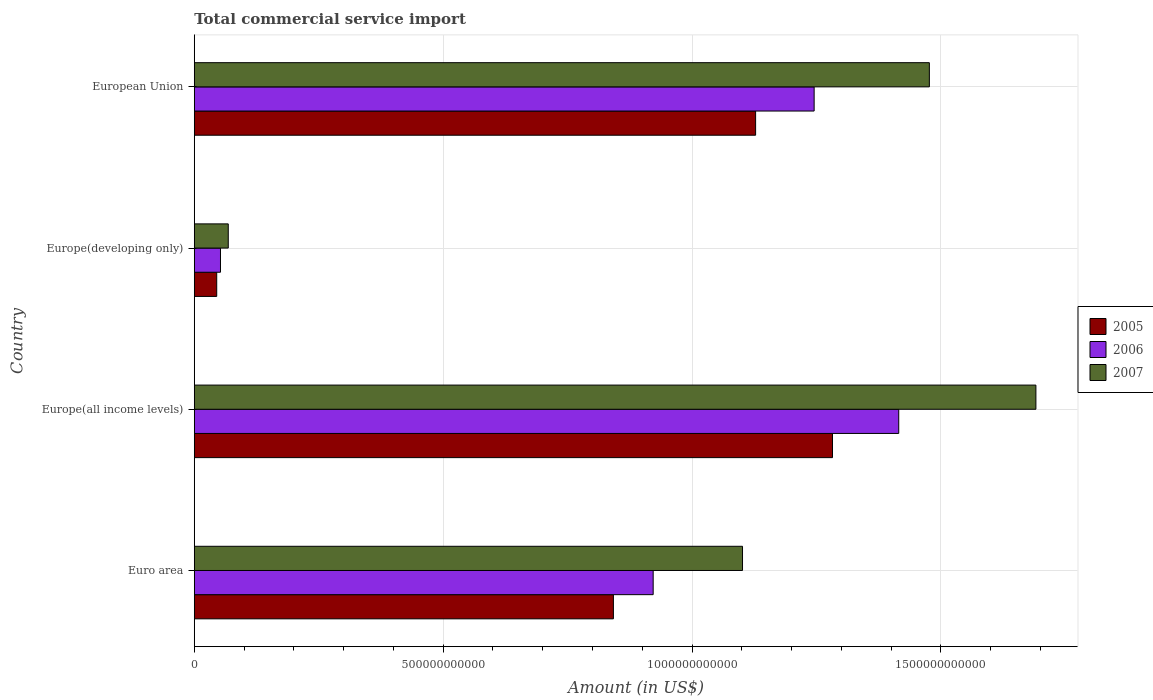How many different coloured bars are there?
Ensure brevity in your answer.  3. What is the label of the 4th group of bars from the top?
Make the answer very short. Euro area. In how many cases, is the number of bars for a given country not equal to the number of legend labels?
Offer a terse response. 0. What is the total commercial service import in 2006 in European Union?
Your response must be concise. 1.25e+12. Across all countries, what is the maximum total commercial service import in 2006?
Provide a succinct answer. 1.42e+12. Across all countries, what is the minimum total commercial service import in 2005?
Make the answer very short. 4.51e+1. In which country was the total commercial service import in 2007 maximum?
Provide a succinct answer. Europe(all income levels). In which country was the total commercial service import in 2005 minimum?
Provide a succinct answer. Europe(developing only). What is the total total commercial service import in 2007 in the graph?
Offer a very short reply. 4.34e+12. What is the difference between the total commercial service import in 2006 in Euro area and that in Europe(developing only)?
Offer a terse response. 8.69e+11. What is the difference between the total commercial service import in 2005 in Euro area and the total commercial service import in 2006 in Europe(all income levels)?
Offer a terse response. -5.73e+11. What is the average total commercial service import in 2005 per country?
Your answer should be compact. 8.24e+11. What is the difference between the total commercial service import in 2005 and total commercial service import in 2007 in Euro area?
Make the answer very short. -2.59e+11. In how many countries, is the total commercial service import in 2005 greater than 700000000000 US$?
Keep it short and to the point. 3. What is the ratio of the total commercial service import in 2007 in Europe(developing only) to that in European Union?
Offer a very short reply. 0.05. Is the total commercial service import in 2005 in Europe(developing only) less than that in European Union?
Provide a short and direct response. Yes. What is the difference between the highest and the second highest total commercial service import in 2007?
Provide a succinct answer. 2.14e+11. What is the difference between the highest and the lowest total commercial service import in 2006?
Provide a short and direct response. 1.36e+12. In how many countries, is the total commercial service import in 2005 greater than the average total commercial service import in 2005 taken over all countries?
Provide a short and direct response. 3. What does the 2nd bar from the bottom in Euro area represents?
Provide a succinct answer. 2006. Are all the bars in the graph horizontal?
Keep it short and to the point. Yes. How many countries are there in the graph?
Ensure brevity in your answer.  4. What is the difference between two consecutive major ticks on the X-axis?
Give a very brief answer. 5.00e+11. How many legend labels are there?
Give a very brief answer. 3. How are the legend labels stacked?
Your answer should be compact. Vertical. What is the title of the graph?
Your answer should be compact. Total commercial service import. What is the Amount (in US$) of 2005 in Euro area?
Give a very brief answer. 8.42e+11. What is the Amount (in US$) in 2006 in Euro area?
Ensure brevity in your answer.  9.22e+11. What is the Amount (in US$) in 2007 in Euro area?
Keep it short and to the point. 1.10e+12. What is the Amount (in US$) in 2005 in Europe(all income levels)?
Make the answer very short. 1.28e+12. What is the Amount (in US$) in 2006 in Europe(all income levels)?
Make the answer very short. 1.42e+12. What is the Amount (in US$) of 2007 in Europe(all income levels)?
Provide a succinct answer. 1.69e+12. What is the Amount (in US$) of 2005 in Europe(developing only)?
Provide a succinct answer. 4.51e+1. What is the Amount (in US$) of 2006 in Europe(developing only)?
Give a very brief answer. 5.27e+1. What is the Amount (in US$) of 2007 in Europe(developing only)?
Give a very brief answer. 6.83e+1. What is the Amount (in US$) in 2005 in European Union?
Give a very brief answer. 1.13e+12. What is the Amount (in US$) in 2006 in European Union?
Offer a terse response. 1.25e+12. What is the Amount (in US$) in 2007 in European Union?
Provide a short and direct response. 1.48e+12. Across all countries, what is the maximum Amount (in US$) in 2005?
Provide a succinct answer. 1.28e+12. Across all countries, what is the maximum Amount (in US$) of 2006?
Your answer should be very brief. 1.42e+12. Across all countries, what is the maximum Amount (in US$) in 2007?
Your response must be concise. 1.69e+12. Across all countries, what is the minimum Amount (in US$) in 2005?
Keep it short and to the point. 4.51e+1. Across all countries, what is the minimum Amount (in US$) of 2006?
Offer a very short reply. 5.27e+1. Across all countries, what is the minimum Amount (in US$) of 2007?
Offer a terse response. 6.83e+1. What is the total Amount (in US$) of 2005 in the graph?
Give a very brief answer. 3.30e+12. What is the total Amount (in US$) of 2006 in the graph?
Ensure brevity in your answer.  3.64e+12. What is the total Amount (in US$) in 2007 in the graph?
Ensure brevity in your answer.  4.34e+12. What is the difference between the Amount (in US$) in 2005 in Euro area and that in Europe(all income levels)?
Your response must be concise. -4.40e+11. What is the difference between the Amount (in US$) of 2006 in Euro area and that in Europe(all income levels)?
Offer a terse response. -4.93e+11. What is the difference between the Amount (in US$) of 2007 in Euro area and that in Europe(all income levels)?
Your answer should be compact. -5.89e+11. What is the difference between the Amount (in US$) of 2005 in Euro area and that in Europe(developing only)?
Make the answer very short. 7.97e+11. What is the difference between the Amount (in US$) of 2006 in Euro area and that in Europe(developing only)?
Provide a short and direct response. 8.69e+11. What is the difference between the Amount (in US$) in 2007 in Euro area and that in Europe(developing only)?
Offer a very short reply. 1.03e+12. What is the difference between the Amount (in US$) of 2005 in Euro area and that in European Union?
Offer a terse response. -2.86e+11. What is the difference between the Amount (in US$) of 2006 in Euro area and that in European Union?
Your answer should be compact. -3.23e+11. What is the difference between the Amount (in US$) of 2007 in Euro area and that in European Union?
Offer a very short reply. -3.75e+11. What is the difference between the Amount (in US$) of 2005 in Europe(all income levels) and that in Europe(developing only)?
Your answer should be compact. 1.24e+12. What is the difference between the Amount (in US$) in 2006 in Europe(all income levels) and that in Europe(developing only)?
Your response must be concise. 1.36e+12. What is the difference between the Amount (in US$) in 2007 in Europe(all income levels) and that in Europe(developing only)?
Your answer should be very brief. 1.62e+12. What is the difference between the Amount (in US$) of 2005 in Europe(all income levels) and that in European Union?
Give a very brief answer. 1.55e+11. What is the difference between the Amount (in US$) in 2006 in Europe(all income levels) and that in European Union?
Your answer should be very brief. 1.70e+11. What is the difference between the Amount (in US$) in 2007 in Europe(all income levels) and that in European Union?
Your answer should be compact. 2.14e+11. What is the difference between the Amount (in US$) of 2005 in Europe(developing only) and that in European Union?
Keep it short and to the point. -1.08e+12. What is the difference between the Amount (in US$) in 2006 in Europe(developing only) and that in European Union?
Offer a terse response. -1.19e+12. What is the difference between the Amount (in US$) in 2007 in Europe(developing only) and that in European Union?
Your response must be concise. -1.41e+12. What is the difference between the Amount (in US$) in 2005 in Euro area and the Amount (in US$) in 2006 in Europe(all income levels)?
Make the answer very short. -5.73e+11. What is the difference between the Amount (in US$) of 2005 in Euro area and the Amount (in US$) of 2007 in Europe(all income levels)?
Offer a terse response. -8.49e+11. What is the difference between the Amount (in US$) in 2006 in Euro area and the Amount (in US$) in 2007 in Europe(all income levels)?
Your answer should be compact. -7.69e+11. What is the difference between the Amount (in US$) in 2005 in Euro area and the Amount (in US$) in 2006 in Europe(developing only)?
Provide a succinct answer. 7.89e+11. What is the difference between the Amount (in US$) in 2005 in Euro area and the Amount (in US$) in 2007 in Europe(developing only)?
Ensure brevity in your answer.  7.74e+11. What is the difference between the Amount (in US$) of 2006 in Euro area and the Amount (in US$) of 2007 in Europe(developing only)?
Keep it short and to the point. 8.54e+11. What is the difference between the Amount (in US$) of 2005 in Euro area and the Amount (in US$) of 2006 in European Union?
Give a very brief answer. -4.03e+11. What is the difference between the Amount (in US$) of 2005 in Euro area and the Amount (in US$) of 2007 in European Union?
Your response must be concise. -6.35e+11. What is the difference between the Amount (in US$) of 2006 in Euro area and the Amount (in US$) of 2007 in European Union?
Your response must be concise. -5.55e+11. What is the difference between the Amount (in US$) of 2005 in Europe(all income levels) and the Amount (in US$) of 2006 in Europe(developing only)?
Your answer should be very brief. 1.23e+12. What is the difference between the Amount (in US$) in 2005 in Europe(all income levels) and the Amount (in US$) in 2007 in Europe(developing only)?
Give a very brief answer. 1.21e+12. What is the difference between the Amount (in US$) of 2006 in Europe(all income levels) and the Amount (in US$) of 2007 in Europe(developing only)?
Offer a very short reply. 1.35e+12. What is the difference between the Amount (in US$) of 2005 in Europe(all income levels) and the Amount (in US$) of 2006 in European Union?
Offer a terse response. 3.69e+1. What is the difference between the Amount (in US$) of 2005 in Europe(all income levels) and the Amount (in US$) of 2007 in European Union?
Your response must be concise. -1.95e+11. What is the difference between the Amount (in US$) of 2006 in Europe(all income levels) and the Amount (in US$) of 2007 in European Union?
Your answer should be compact. -6.15e+1. What is the difference between the Amount (in US$) in 2005 in Europe(developing only) and the Amount (in US$) in 2006 in European Union?
Give a very brief answer. -1.20e+12. What is the difference between the Amount (in US$) of 2005 in Europe(developing only) and the Amount (in US$) of 2007 in European Union?
Provide a short and direct response. -1.43e+12. What is the difference between the Amount (in US$) of 2006 in Europe(developing only) and the Amount (in US$) of 2007 in European Union?
Your response must be concise. -1.42e+12. What is the average Amount (in US$) in 2005 per country?
Provide a short and direct response. 8.24e+11. What is the average Amount (in US$) of 2006 per country?
Your response must be concise. 9.09e+11. What is the average Amount (in US$) of 2007 per country?
Provide a short and direct response. 1.08e+12. What is the difference between the Amount (in US$) in 2005 and Amount (in US$) in 2006 in Euro area?
Make the answer very short. -7.99e+1. What is the difference between the Amount (in US$) of 2005 and Amount (in US$) of 2007 in Euro area?
Ensure brevity in your answer.  -2.59e+11. What is the difference between the Amount (in US$) in 2006 and Amount (in US$) in 2007 in Euro area?
Offer a very short reply. -1.80e+11. What is the difference between the Amount (in US$) in 2005 and Amount (in US$) in 2006 in Europe(all income levels)?
Ensure brevity in your answer.  -1.33e+11. What is the difference between the Amount (in US$) of 2005 and Amount (in US$) of 2007 in Europe(all income levels)?
Provide a short and direct response. -4.09e+11. What is the difference between the Amount (in US$) in 2006 and Amount (in US$) in 2007 in Europe(all income levels)?
Ensure brevity in your answer.  -2.76e+11. What is the difference between the Amount (in US$) in 2005 and Amount (in US$) in 2006 in Europe(developing only)?
Make the answer very short. -7.54e+09. What is the difference between the Amount (in US$) in 2005 and Amount (in US$) in 2007 in Europe(developing only)?
Your response must be concise. -2.32e+1. What is the difference between the Amount (in US$) in 2006 and Amount (in US$) in 2007 in Europe(developing only)?
Offer a very short reply. -1.56e+1. What is the difference between the Amount (in US$) in 2005 and Amount (in US$) in 2006 in European Union?
Provide a short and direct response. -1.18e+11. What is the difference between the Amount (in US$) in 2005 and Amount (in US$) in 2007 in European Union?
Give a very brief answer. -3.49e+11. What is the difference between the Amount (in US$) of 2006 and Amount (in US$) of 2007 in European Union?
Offer a terse response. -2.31e+11. What is the ratio of the Amount (in US$) in 2005 in Euro area to that in Europe(all income levels)?
Make the answer very short. 0.66. What is the ratio of the Amount (in US$) in 2006 in Euro area to that in Europe(all income levels)?
Your answer should be very brief. 0.65. What is the ratio of the Amount (in US$) of 2007 in Euro area to that in Europe(all income levels)?
Give a very brief answer. 0.65. What is the ratio of the Amount (in US$) of 2005 in Euro area to that in Europe(developing only)?
Offer a very short reply. 18.66. What is the ratio of the Amount (in US$) of 2006 in Euro area to that in Europe(developing only)?
Your response must be concise. 17.51. What is the ratio of the Amount (in US$) in 2007 in Euro area to that in Europe(developing only)?
Ensure brevity in your answer.  16.13. What is the ratio of the Amount (in US$) of 2005 in Euro area to that in European Union?
Offer a terse response. 0.75. What is the ratio of the Amount (in US$) of 2006 in Euro area to that in European Union?
Provide a succinct answer. 0.74. What is the ratio of the Amount (in US$) in 2007 in Euro area to that in European Union?
Your answer should be very brief. 0.75. What is the ratio of the Amount (in US$) in 2005 in Europe(all income levels) to that in Europe(developing only)?
Offer a very short reply. 28.42. What is the ratio of the Amount (in US$) in 2006 in Europe(all income levels) to that in Europe(developing only)?
Your response must be concise. 26.88. What is the ratio of the Amount (in US$) of 2007 in Europe(all income levels) to that in Europe(developing only)?
Your answer should be compact. 24.76. What is the ratio of the Amount (in US$) of 2005 in Europe(all income levels) to that in European Union?
Offer a terse response. 1.14. What is the ratio of the Amount (in US$) in 2006 in Europe(all income levels) to that in European Union?
Keep it short and to the point. 1.14. What is the ratio of the Amount (in US$) of 2007 in Europe(all income levels) to that in European Union?
Ensure brevity in your answer.  1.14. What is the ratio of the Amount (in US$) in 2006 in Europe(developing only) to that in European Union?
Offer a terse response. 0.04. What is the ratio of the Amount (in US$) in 2007 in Europe(developing only) to that in European Union?
Provide a succinct answer. 0.05. What is the difference between the highest and the second highest Amount (in US$) in 2005?
Provide a short and direct response. 1.55e+11. What is the difference between the highest and the second highest Amount (in US$) in 2006?
Offer a terse response. 1.70e+11. What is the difference between the highest and the second highest Amount (in US$) of 2007?
Your answer should be very brief. 2.14e+11. What is the difference between the highest and the lowest Amount (in US$) in 2005?
Your answer should be compact. 1.24e+12. What is the difference between the highest and the lowest Amount (in US$) in 2006?
Your answer should be compact. 1.36e+12. What is the difference between the highest and the lowest Amount (in US$) of 2007?
Your answer should be very brief. 1.62e+12. 